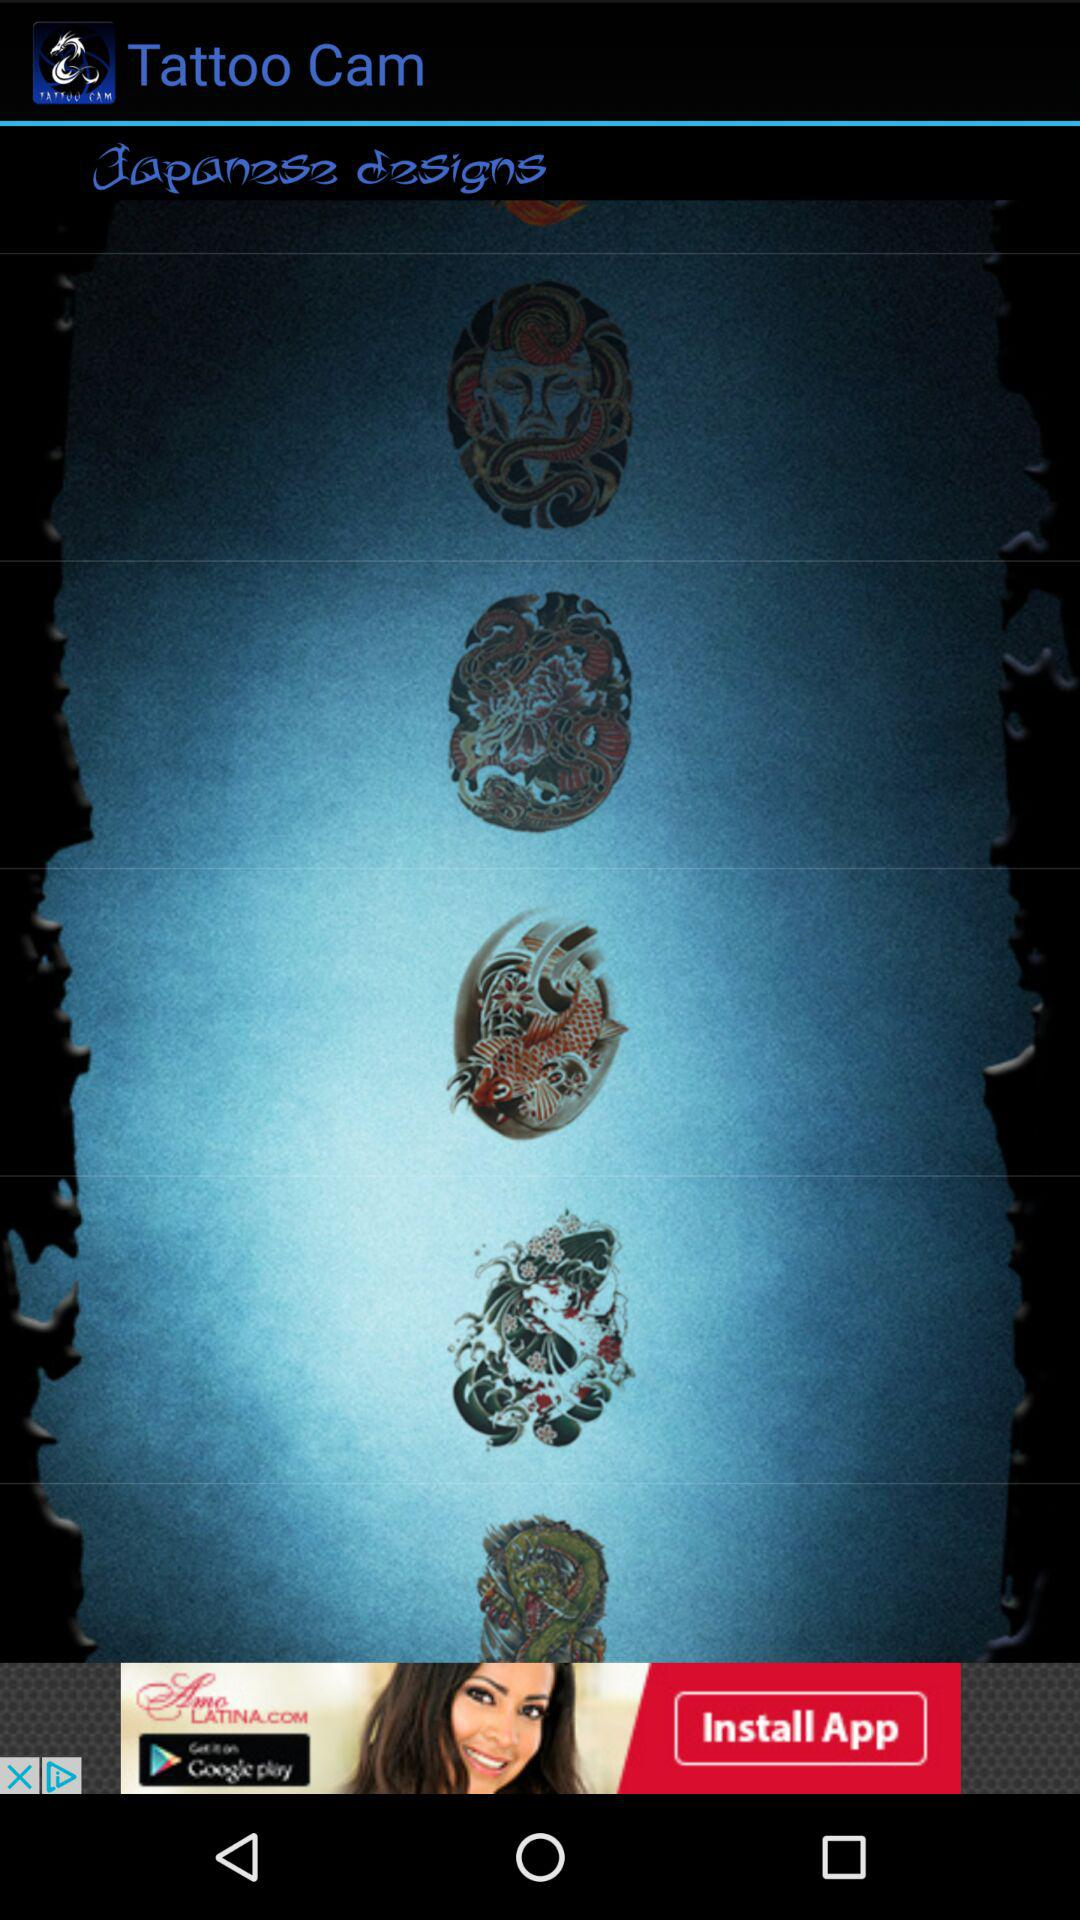What is the name of the application? The name of the application is "Tattoo Cam". 